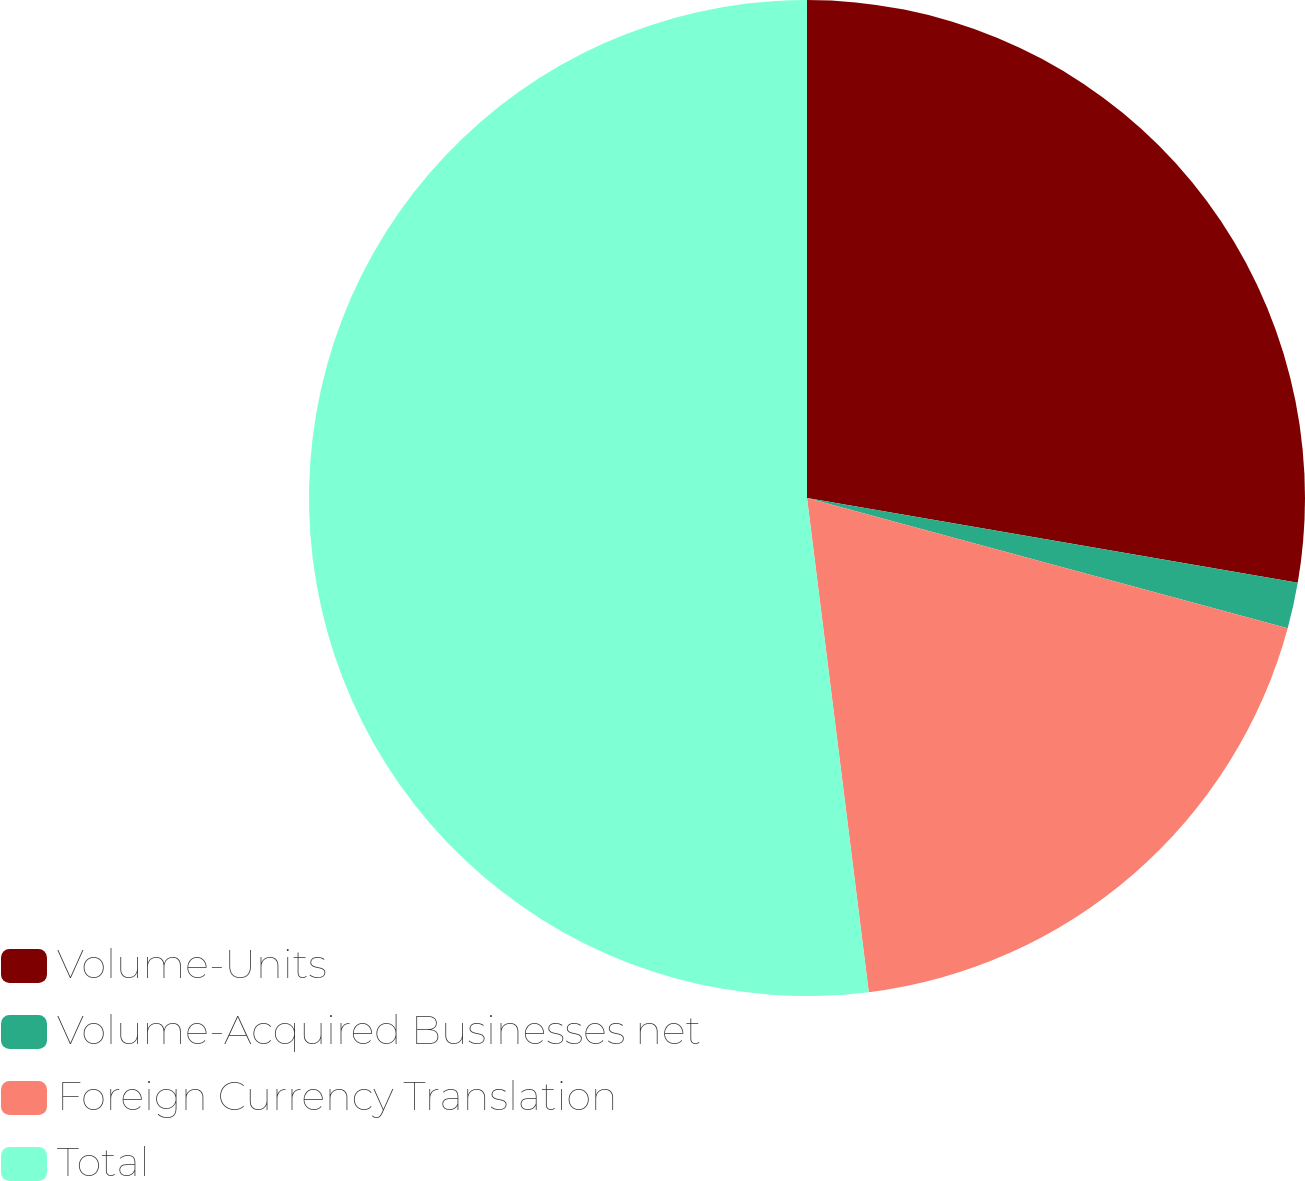Convert chart. <chart><loc_0><loc_0><loc_500><loc_500><pie_chart><fcel>Volume-Units<fcel>Volume-Acquired Businesses net<fcel>Foreign Currency Translation<fcel>Total<nl><fcel>27.72%<fcel>1.49%<fcel>18.81%<fcel>51.98%<nl></chart> 